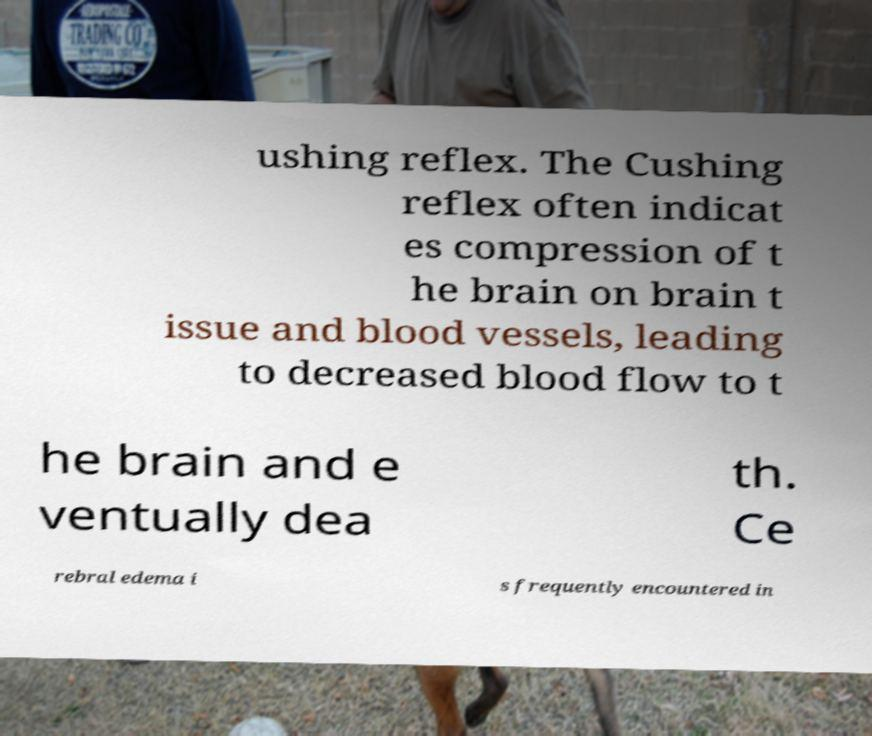Can you read and provide the text displayed in the image?This photo seems to have some interesting text. Can you extract and type it out for me? ushing reflex. The Cushing reflex often indicat es compression of t he brain on brain t issue and blood vessels, leading to decreased blood flow to t he brain and e ventually dea th. Ce rebral edema i s frequently encountered in 